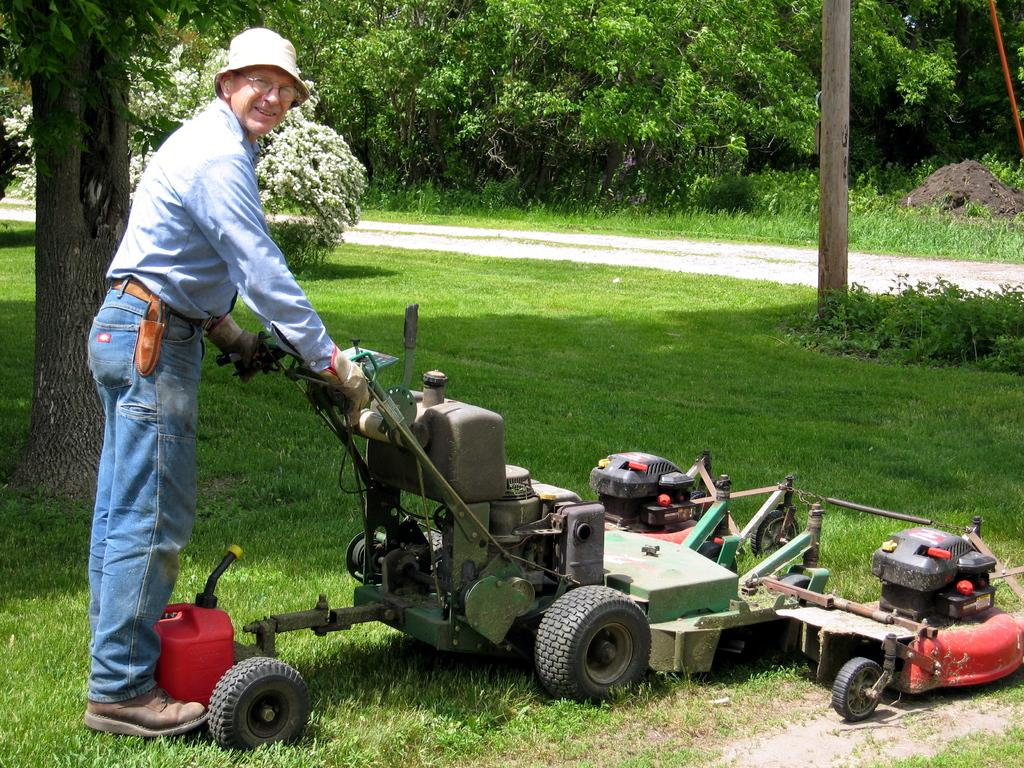Who is present in the image? There is a man in the image. What is the man doing in the image? The man is standing and holding a lawn mower. What type of surface is visible at the bottom of the image? There is grass at the bottom of the image. What can be seen in the distance in the image? There are trees in the background of the image. What type of power does the man have over the trees in the image? The man does not have any power over the trees in the image, as he is holding a lawn mower and standing on grass. 